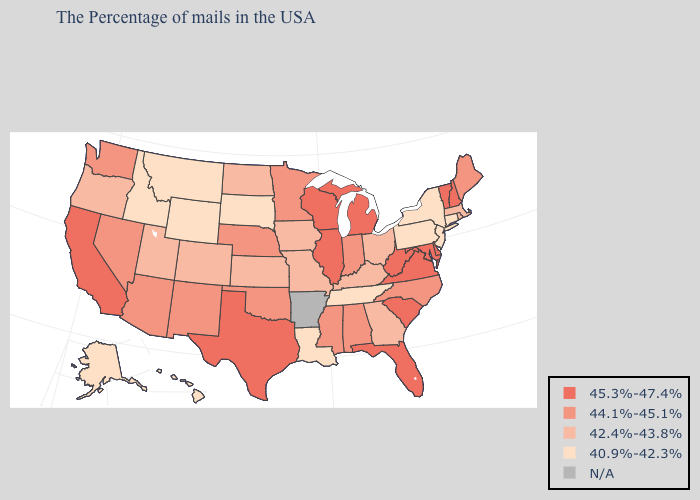Among the states that border Indiana , which have the lowest value?
Concise answer only. Ohio, Kentucky. Which states have the lowest value in the USA?
Short answer required. Connecticut, New York, New Jersey, Pennsylvania, Tennessee, Louisiana, South Dakota, Wyoming, Montana, Idaho, Alaska, Hawaii. What is the lowest value in the USA?
Be succinct. 40.9%-42.3%. Name the states that have a value in the range 44.1%-45.1%?
Answer briefly. Maine, North Carolina, Indiana, Alabama, Mississippi, Minnesota, Nebraska, Oklahoma, New Mexico, Arizona, Nevada, Washington. Among the states that border Virginia , does North Carolina have the highest value?
Answer briefly. No. Which states hav the highest value in the West?
Short answer required. California. Which states hav the highest value in the South?
Concise answer only. Delaware, Maryland, Virginia, South Carolina, West Virginia, Florida, Texas. Name the states that have a value in the range 42.4%-43.8%?
Give a very brief answer. Massachusetts, Rhode Island, Ohio, Georgia, Kentucky, Missouri, Iowa, Kansas, North Dakota, Colorado, Utah, Oregon. Which states have the lowest value in the West?
Quick response, please. Wyoming, Montana, Idaho, Alaska, Hawaii. What is the highest value in states that border Arkansas?
Keep it brief. 45.3%-47.4%. Name the states that have a value in the range 44.1%-45.1%?
Write a very short answer. Maine, North Carolina, Indiana, Alabama, Mississippi, Minnesota, Nebraska, Oklahoma, New Mexico, Arizona, Nevada, Washington. What is the value of New York?
Concise answer only. 40.9%-42.3%. Which states hav the highest value in the Northeast?
Be succinct. New Hampshire, Vermont. Which states have the lowest value in the MidWest?
Short answer required. South Dakota. 